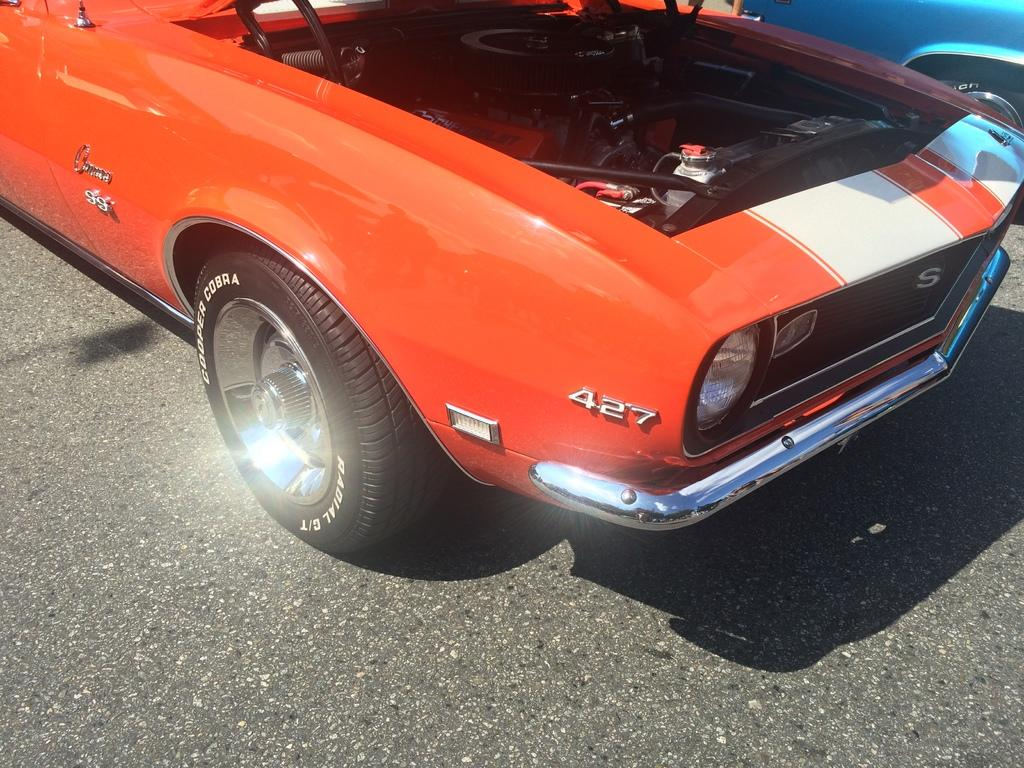What is the main subject in the foreground of the image? There is a car in the foreground of the image. Where is the car located? The car is on a road. Can you see any other vehicles in the image? Yes, there is another car visible in the top right of the image. What type of cracker is being used to fix the car in the image? There is no cracker present in the image, nor is there any indication that the car is being fixed. 